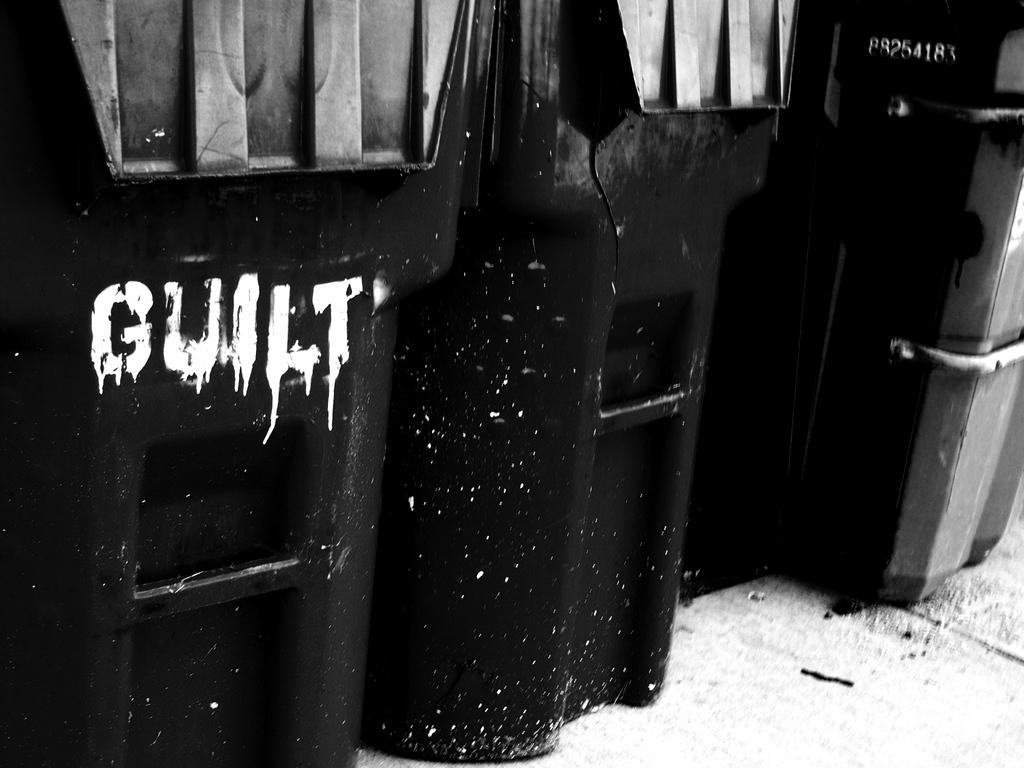Describe this image in one or two sentences. In this image there are so many bins kept on a row and GUILT is written on one of them. 